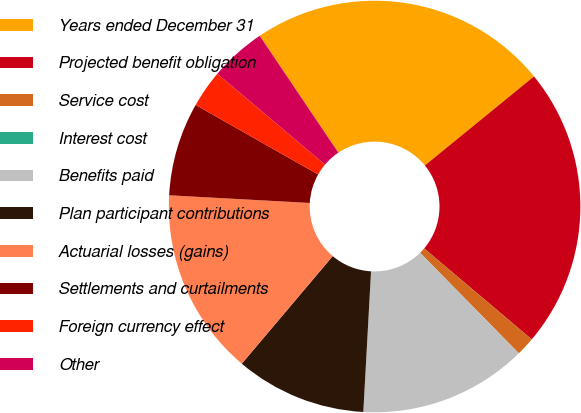Convert chart to OTSL. <chart><loc_0><loc_0><loc_500><loc_500><pie_chart><fcel>Years ended December 31<fcel>Projected benefit obligation<fcel>Service cost<fcel>Interest cost<fcel>Benefits paid<fcel>Plan participant contributions<fcel>Actuarial losses (gains)<fcel>Settlements and curtailments<fcel>Foreign currency effect<fcel>Other<nl><fcel>23.53%<fcel>22.06%<fcel>1.47%<fcel>0.0%<fcel>13.23%<fcel>10.29%<fcel>14.7%<fcel>7.35%<fcel>2.94%<fcel>4.41%<nl></chart> 